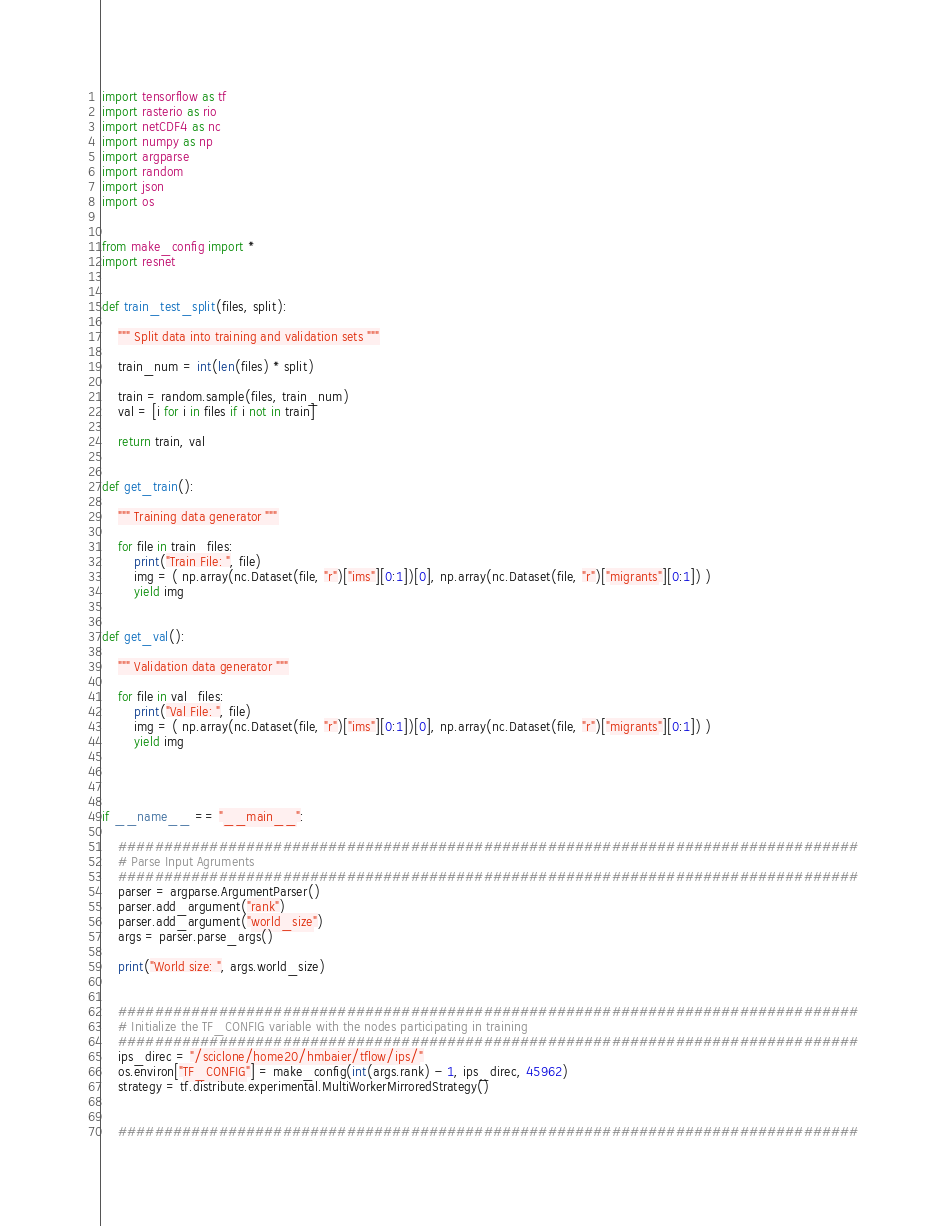Convert code to text. <code><loc_0><loc_0><loc_500><loc_500><_Python_>import tensorflow as tf
import rasterio as rio
import netCDF4 as nc
import numpy as np
import argparse
import random
import json
import os


from make_config import *
import resnet


def train_test_split(files, split):

    """ Split data into training and validation sets """

    train_num = int(len(files) * split)

    train = random.sample(files, train_num)
    val = [i for i in files if i not in train]

    return train, val


def get_train():

    """ Training data generator """

    for file in train_files:
        print("Train File: ", file)
        img = ( np.array(nc.Dataset(file, "r")["ims"][0:1])[0], np.array(nc.Dataset(file, "r")["migrants"][0:1]) )
        yield img


def get_val():

    """ Validation data generator """

    for file in val_files:
        print("Val File: ", file)
        img = ( np.array(nc.Dataset(file, "r")["ims"][0:1])[0], np.array(nc.Dataset(file, "r")["migrants"][0:1]) )
        yield img




if __name__ == "__main__":

    #################################################################################
    # Parse Input Agruments
    #################################################################################
    parser = argparse.ArgumentParser()
    parser.add_argument("rank")
    parser.add_argument("world_size")
    args = parser.parse_args()

    print("World size: ", args.world_size)


    #################################################################################
    # Initialize the TF_CONFIG variable with the nodes participating in training
    #################################################################################
    ips_direc = "/sciclone/home20/hmbaier/tflow/ips/"
    os.environ["TF_CONFIG"] = make_config(int(args.rank) - 1, ips_direc, 45962)
    strategy = tf.distribute.experimental.MultiWorkerMirroredStrategy()


    #################################################################################</code> 